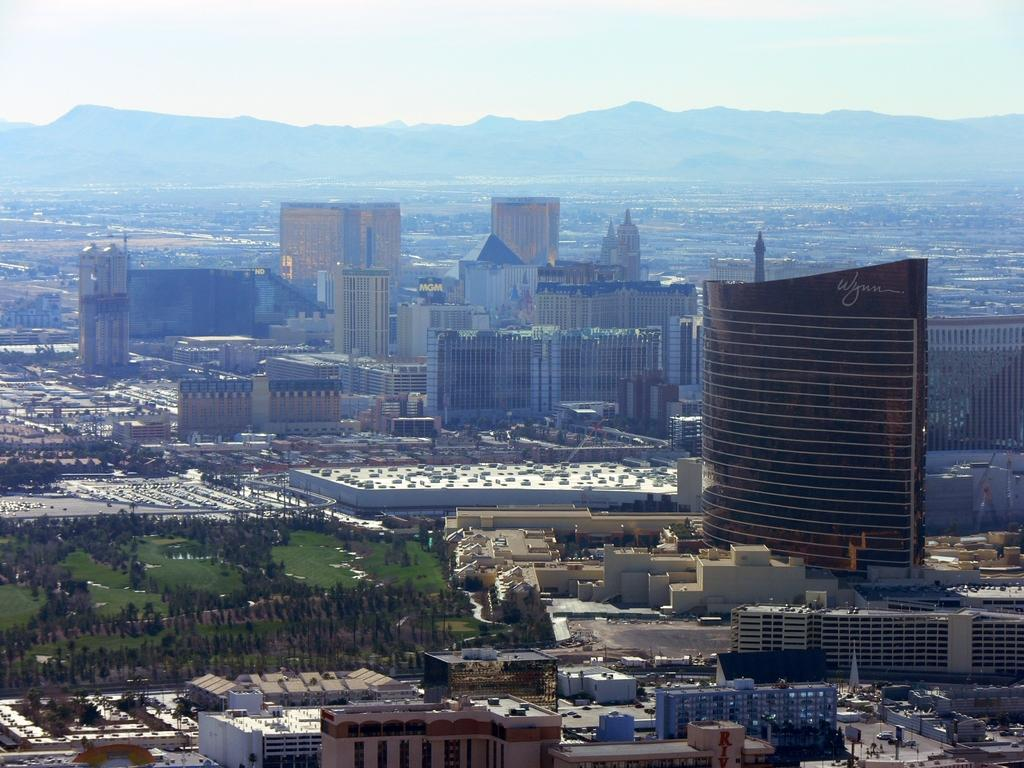What type of structures can be seen in the image? There are buildings in the image. What natural elements are present in the image? There are trees and grass in the image. What man-made objects can be seen in the image? There are vehicles and boards on poles in the image. What can be seen in the distance in the image? There are hills visible in the background of the image. What part of the natural environment is visible in the image? The sky is visible in the background of the image. How many beans are present in the image? There are no beans visible in the image. What type of science is being conducted in the image? There is no indication of any scientific activity in the image. 